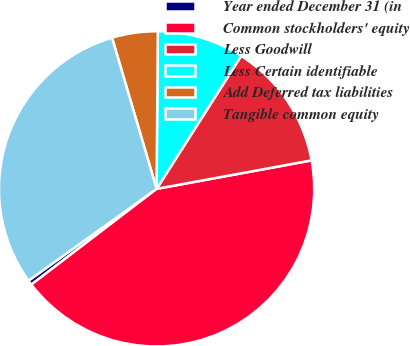<chart> <loc_0><loc_0><loc_500><loc_500><pie_chart><fcel>Year ended December 31 (in<fcel>Common stockholders' equity<fcel>Less Goodwill<fcel>Less Certain identifiable<fcel>Add Deferred tax liabilities<fcel>Tangible common equity<nl><fcel>0.49%<fcel>42.5%<fcel>13.09%<fcel>8.89%<fcel>4.69%<fcel>30.33%<nl></chart> 